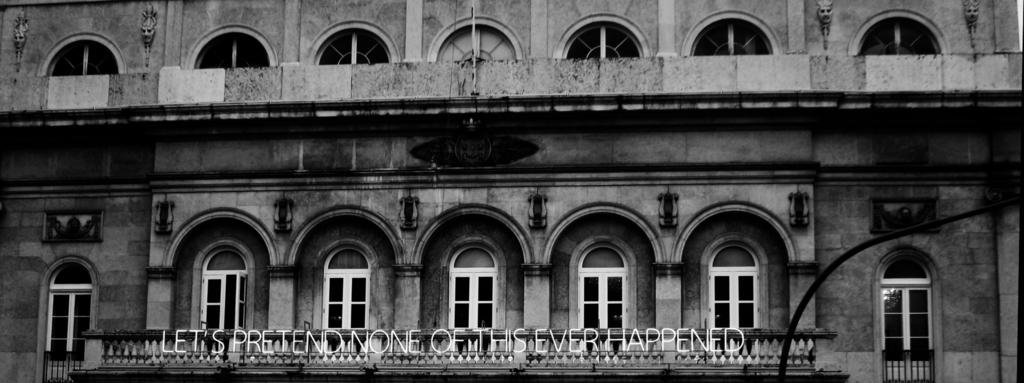What is the color scheme of the image? The image is black and white. What type of structure is present in the image? There is a building in the image. What feature can be seen on the building? The building has glass window balconies. What type of barrier is visible in the image? There is a concrete fence in the image. Is there any text or writing present in the image? Yes, there is some text on the concrete fence. Can you see a drum being played on the sidewalk in the image? There is no drum or sidewalk present in the image. 